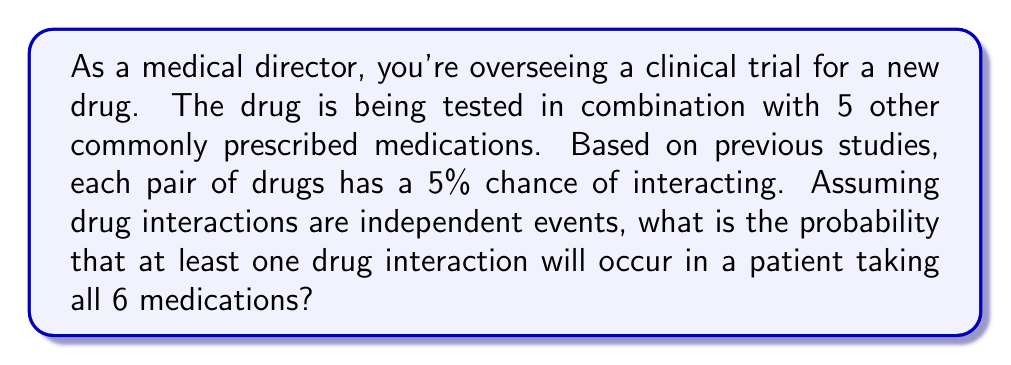Teach me how to tackle this problem. To solve this problem, we'll use the following approach:

1. Calculate the total number of possible drug pairs
2. Determine the probability of no interactions occurring
3. Subtract this probability from 1 to find the probability of at least one interaction

Step 1: Calculate the number of possible drug pairs
With 6 drugs, we can calculate the number of pairs using the combination formula:

$${6 \choose 2} = \frac{6!}{2!(6-2)!} = \frac{6 \cdot 5}{2} = 15$$

Step 2: Determine the probability of no interactions occurring
The probability of no interaction for each pair is 95% (1 - 5% = 0.95). For all 15 pairs to have no interaction, we multiply these probabilities:

$$P(\text{no interactions}) = 0.95^{15}$$

Step 3: Calculate the probability of at least one interaction
The probability of at least one interaction is the complement of the probability of no interactions:

$$P(\text{at least one interaction}) = 1 - P(\text{no interactions})$$
$$= 1 - 0.95^{15}$$
$$= 1 - 0.4633$$
$$= 0.5367$$

Therefore, the probability of at least one drug interaction occurring is approximately 0.5367 or 53.67%.
Answer: The probability that at least one drug interaction will occur in a patient taking all 6 medications is approximately 0.5367 or 53.67%. 